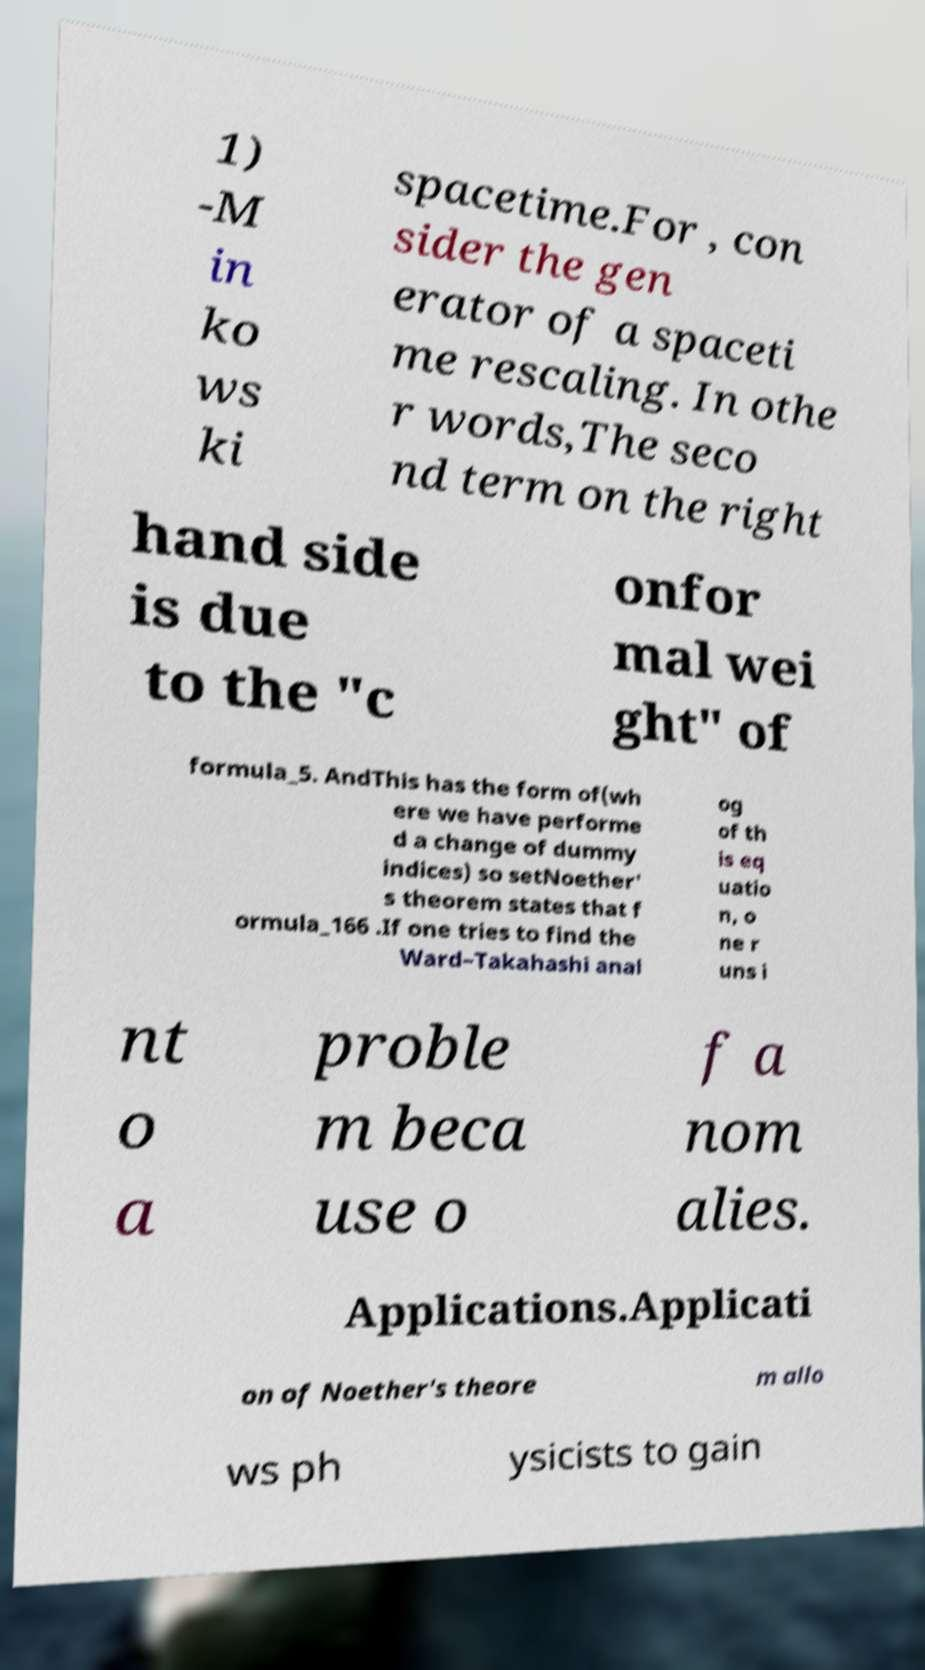There's text embedded in this image that I need extracted. Can you transcribe it verbatim? 1) -M in ko ws ki spacetime.For , con sider the gen erator of a spaceti me rescaling. In othe r words,The seco nd term on the right hand side is due to the "c onfor mal wei ght" of formula_5. AndThis has the form of(wh ere we have performe d a change of dummy indices) so setNoether' s theorem states that f ormula_166 .If one tries to find the Ward–Takahashi anal og of th is eq uatio n, o ne r uns i nt o a proble m beca use o f a nom alies. Applications.Applicati on of Noether's theore m allo ws ph ysicists to gain 